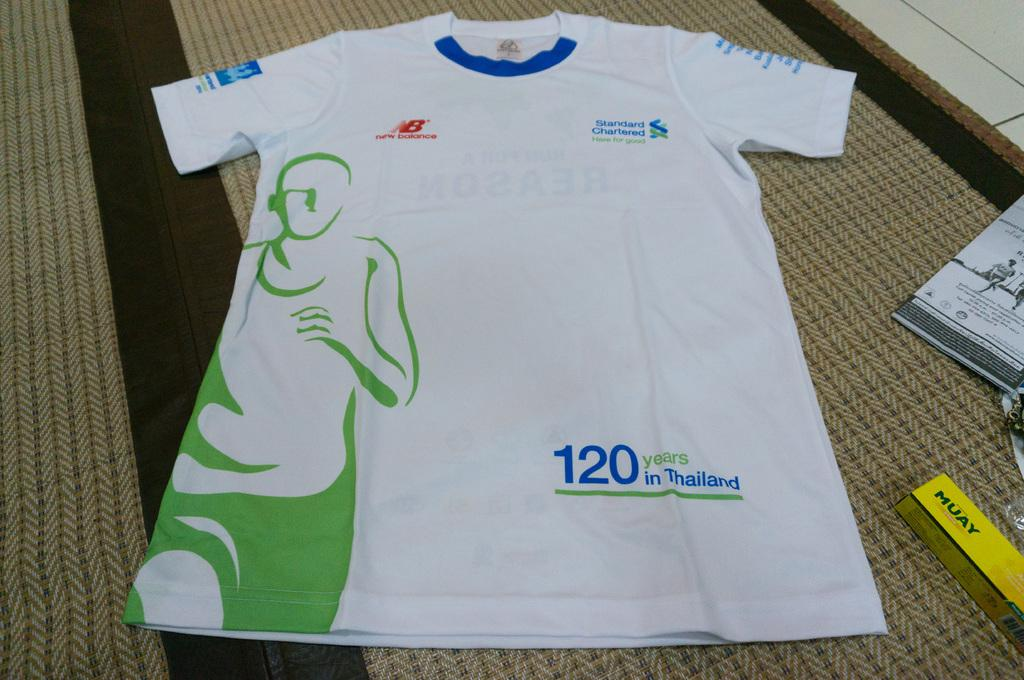<image>
Summarize the visual content of the image. A shirt that says 120 years in Thailand 